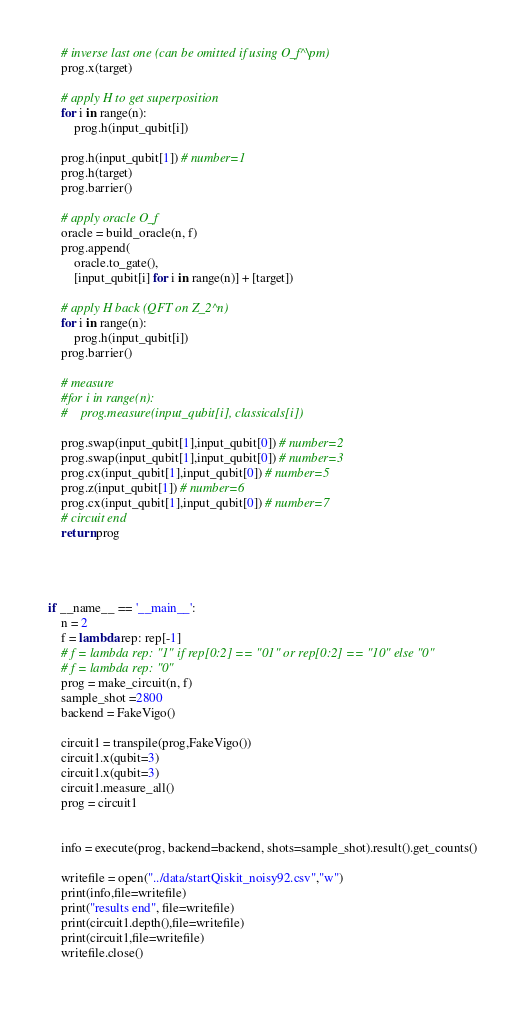Convert code to text. <code><loc_0><loc_0><loc_500><loc_500><_Python_>    # inverse last one (can be omitted if using O_f^\pm)
    prog.x(target)

    # apply H to get superposition
    for i in range(n):
        prog.h(input_qubit[i])

    prog.h(input_qubit[1]) # number=1
    prog.h(target)
    prog.barrier()

    # apply oracle O_f
    oracle = build_oracle(n, f)
    prog.append(
        oracle.to_gate(),
        [input_qubit[i] for i in range(n)] + [target])

    # apply H back (QFT on Z_2^n)
    for i in range(n):
        prog.h(input_qubit[i])
    prog.barrier()

    # measure
    #for i in range(n):
    #    prog.measure(input_qubit[i], classicals[i])

    prog.swap(input_qubit[1],input_qubit[0]) # number=2
    prog.swap(input_qubit[1],input_qubit[0]) # number=3
    prog.cx(input_qubit[1],input_qubit[0]) # number=5
    prog.z(input_qubit[1]) # number=6
    prog.cx(input_qubit[1],input_qubit[0]) # number=7
    # circuit end
    return prog




if __name__ == '__main__':
    n = 2
    f = lambda rep: rep[-1]
    # f = lambda rep: "1" if rep[0:2] == "01" or rep[0:2] == "10" else "0"
    # f = lambda rep: "0"
    prog = make_circuit(n, f)
    sample_shot =2800
    backend = FakeVigo()

    circuit1 = transpile(prog,FakeVigo())
    circuit1.x(qubit=3)
    circuit1.x(qubit=3)
    circuit1.measure_all()
    prog = circuit1


    info = execute(prog, backend=backend, shots=sample_shot).result().get_counts()

    writefile = open("../data/startQiskit_noisy92.csv","w")
    print(info,file=writefile)
    print("results end", file=writefile)
    print(circuit1.depth(),file=writefile)
    print(circuit1,file=writefile)
    writefile.close()
</code> 